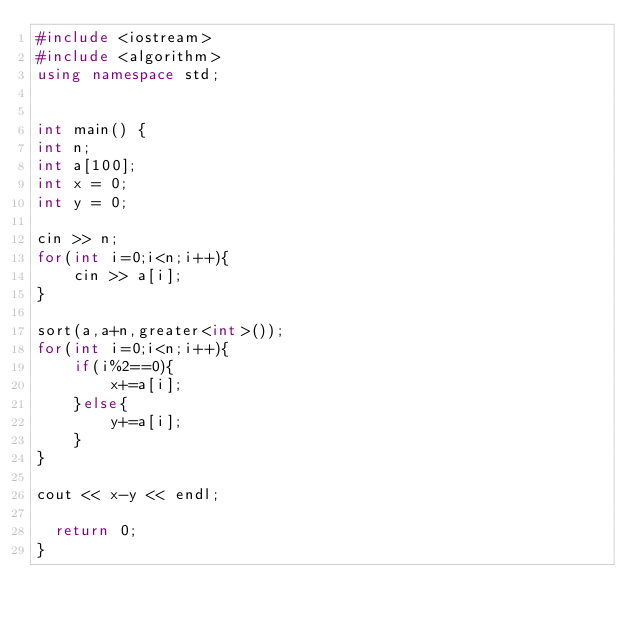<code> <loc_0><loc_0><loc_500><loc_500><_C++_>#include <iostream>
#include <algorithm>
using namespace std;


int main() {
int n;
int a[100];
int x = 0;
int y = 0;

cin >> n;
for(int i=0;i<n;i++){
    cin >> a[i];
}

sort(a,a+n,greater<int>());
for(int i=0;i<n;i++){
    if(i%2==0){
        x+=a[i];
    }else{
        y+=a[i];
    }
}

cout << x-y << endl;

	return 0;
}</code> 